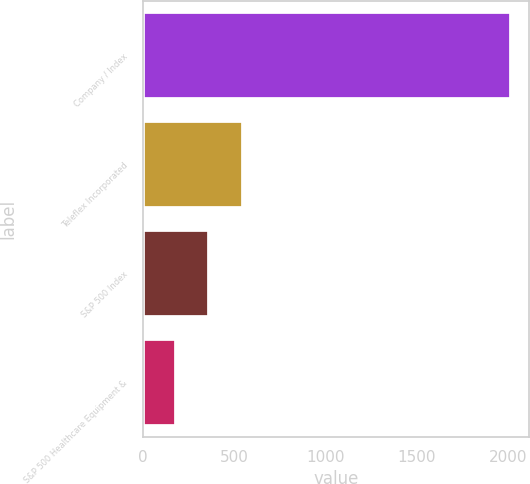Convert chart. <chart><loc_0><loc_0><loc_500><loc_500><bar_chart><fcel>Company / Index<fcel>Teleflex Incorporated<fcel>S&P 500 Index<fcel>S&P 500 Healthcare Equipment &<nl><fcel>2014<fcel>548.4<fcel>365.2<fcel>182<nl></chart> 